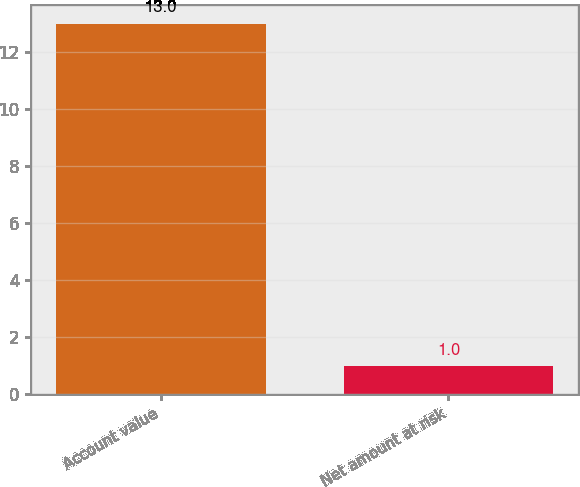Convert chart. <chart><loc_0><loc_0><loc_500><loc_500><bar_chart><fcel>Account value<fcel>Net amount at risk<nl><fcel>13<fcel>1<nl></chart> 